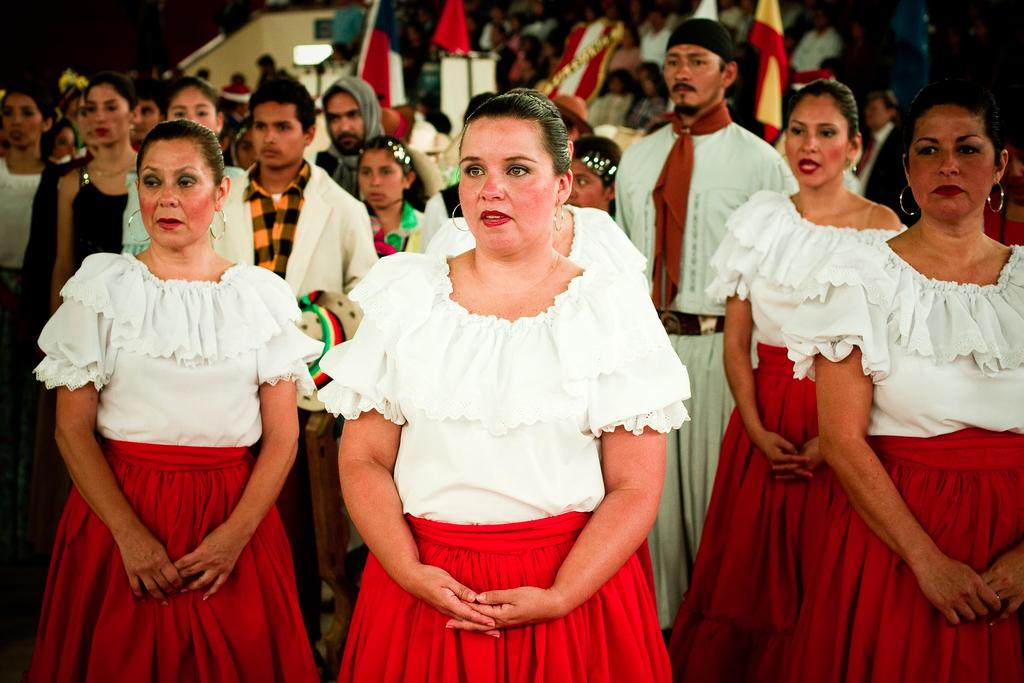How many groups of people are visible in the image? There are two groups of people visible in the image. What can be seen in the background of the image? In the background of the image, there are plants, a building, and flags. Can you describe the setting of the image? The image appears to be set in an outdoor area with a group of people in the foreground and another group in the background, along with various background elements such as plants, a building, and flags. What type of art is being created by the baby in the image? There is no baby present in the image, and therefore no art being created by a baby. 